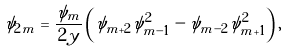<formula> <loc_0><loc_0><loc_500><loc_500>\psi _ { 2 m } = \frac { \psi _ { m } } { 2 y } \left ( \psi _ { m + 2 } \psi _ { m - 1 } ^ { 2 } - \psi _ { m - 2 } \psi _ { m + 1 } ^ { 2 } \right ) ,</formula> 